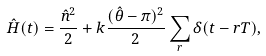<formula> <loc_0><loc_0><loc_500><loc_500>\hat { H } ( t ) = \frac { \hat { n } ^ { 2 } } { 2 } + k \frac { ( \hat { \theta } - \pi ) ^ { 2 } } { 2 } \sum _ { r } \delta ( t - r T ) ,</formula> 